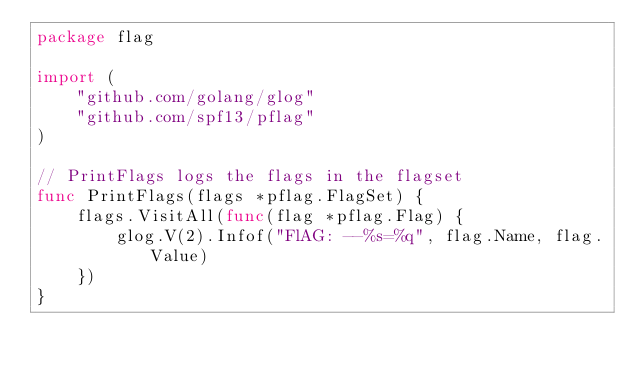<code> <loc_0><loc_0><loc_500><loc_500><_Go_>package flag

import (
	"github.com/golang/glog"
	"github.com/spf13/pflag"
)

// PrintFlags logs the flags in the flagset
func PrintFlags(flags *pflag.FlagSet) {
	flags.VisitAll(func(flag *pflag.Flag) {
		glog.V(2).Infof("FlAG: --%s=%q", flag.Name, flag.Value)
	})
}
</code> 